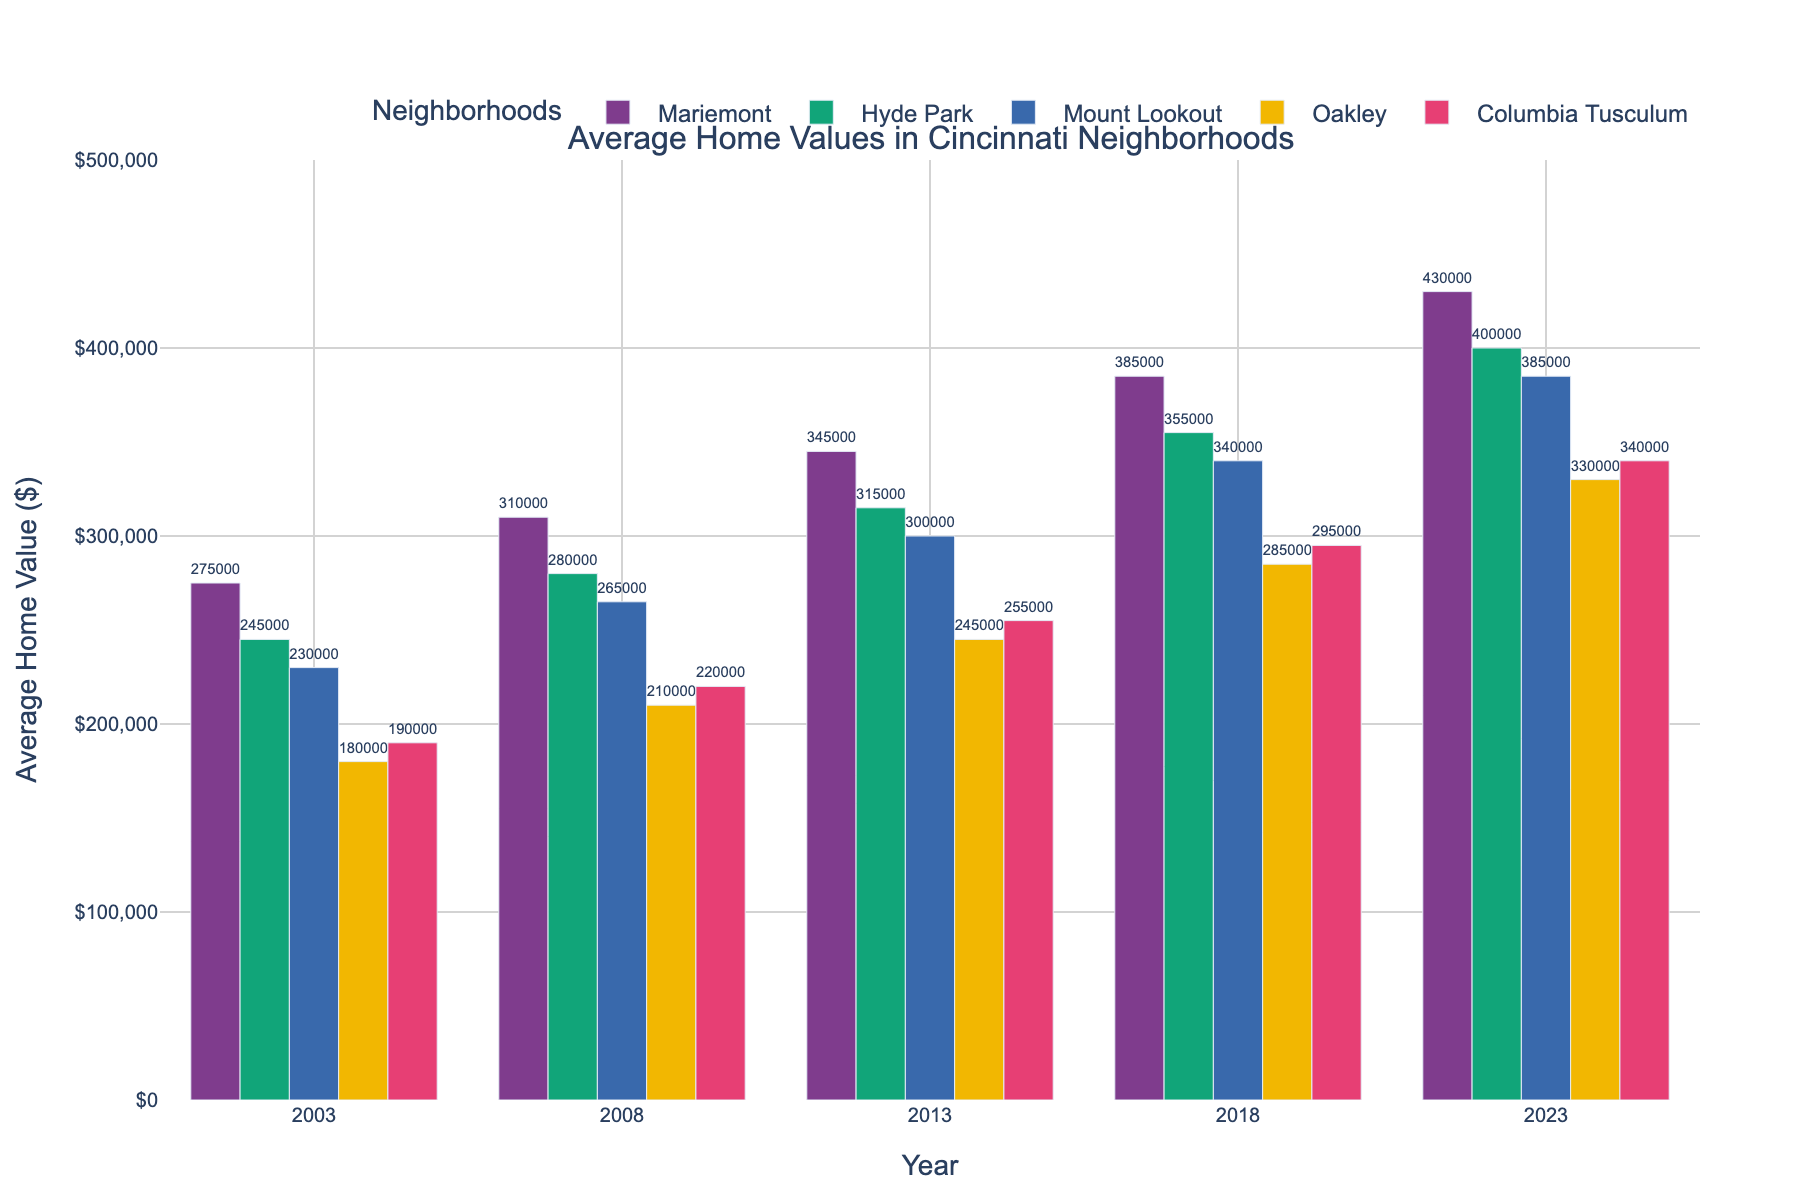What neighborhood had the highest average home value in 2023? Look at the value for 2023 and compare among the neighborhoods. Mariemont has the highest value at $430,000.
Answer: Mariemont How much did the average home value in Oakley increase from 2003 to 2023? Subtract the value of Oakley in 2003 from the value in 2023: $330,000 - $180,000 = $150,000.
Answer: $150,000 Which neighborhood experienced the second smallest increase in average home value between 2003 and 2023? Calculate the increase in each neighborhood and compare: Hyde Park ($155,000), Mount Lookout ($155,000), Columbia Tusculum ($150,000), Mariemont ($155,000), Oakley ($150,000). The second smallest increase is in Hyde Park, Mount Lookout, and Mariemont which are all tied.
Answer: Hyde Park, Mount Lookout, Mariemont What is the difference in average home values between Mariemont and Columbia Tusculum in 2008? Subtract Columbia Tusculum's value from Mariemont's value in 2008: $310,000 - $220,000 = $90,000.
Answer: $90,000 Which neighborhood had the least average home value in 2013? Compare the 2013 values for each neighborhood. Oakley has the least at $245,000.
Answer: Oakley How did the average home values change overall from 2003 to 2023 for Mariemont and Mount Lookout combined? Calculate the increase for each neighborhood separately and then sum the increases: Mariemont ($430,000 - $275,000 = $155,000) and Mount Lookout ($385,000 - $230,000 = $155,000). Sum the increases: $155,000 + $155,000 = $310,000.
Answer: $310,000 By how much did the average home value in Hyde Park surpass that of Oakley in 2018? Subtract Oakley's value from Hyde Park's value in 2018: $355,000 - $285,000 = $70,000.
Answer: $70,000 Between which consecutive years did Mariemont experience the largest increase in average home value? Calculate the differences between consecutive years: 
2003 to 2008: $310,000 - $275,000 = $35,000
2008 to 2013: $345,000 - $310,000 = $35,000
2013 to 2018: $385,000 - $345,000 = $40,000
2018 to 2023: $430,000 - $385,000 = $45,000
The largest is between 2018 and 2023 at $45,000.
Answer: 2018 to 2023 Which neighborhood showed the most consistent increase in average home values over the 20 years? Look at the values over the years and observe which neighborhood shows the most steady increments without fluctuating increments. Mariemont shows the values $275,000, $310,000, $345,000, $385,000, $430,000 with steady increases.
Answer: Mariemont In 2013, how much higher was the average home value in Hyde Park compared to Columbia Tusculum? Subtract Columbia Tusculum's value from Hyde Park's value in 2013: $315,000 - $255,000 = $60,000.
Answer: $60,000 